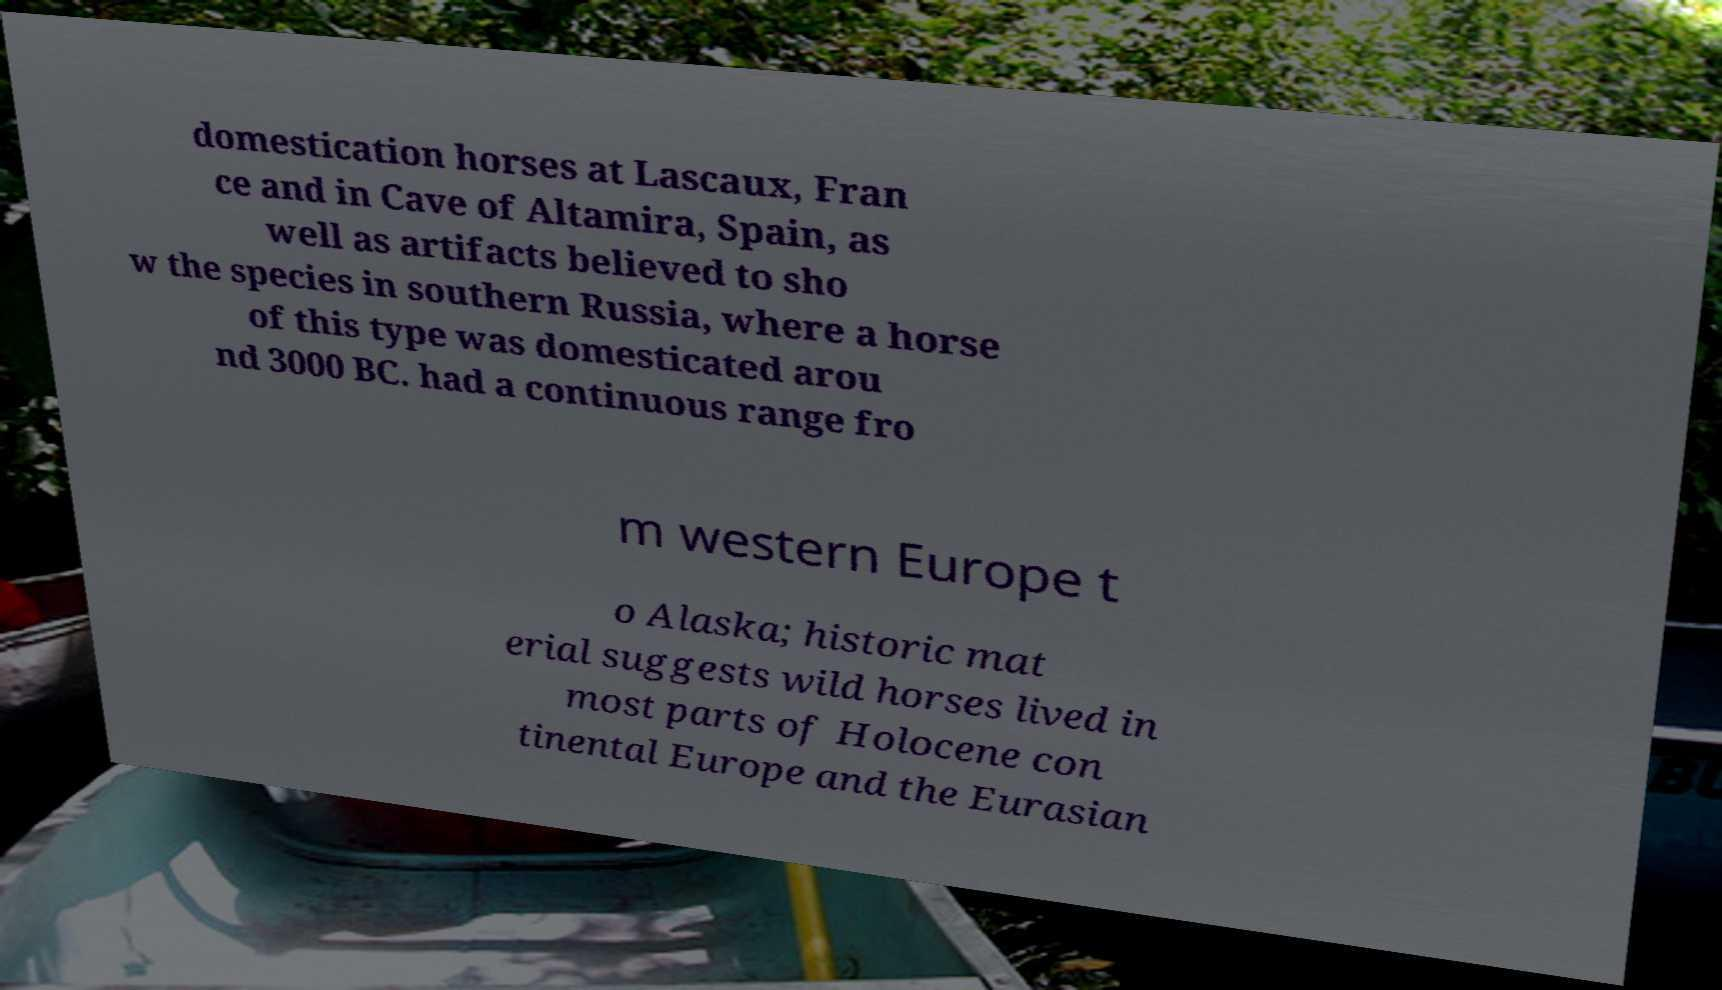Could you extract and type out the text from this image? domestication horses at Lascaux, Fran ce and in Cave of Altamira, Spain, as well as artifacts believed to sho w the species in southern Russia, where a horse of this type was domesticated arou nd 3000 BC. had a continuous range fro m western Europe t o Alaska; historic mat erial suggests wild horses lived in most parts of Holocene con tinental Europe and the Eurasian 